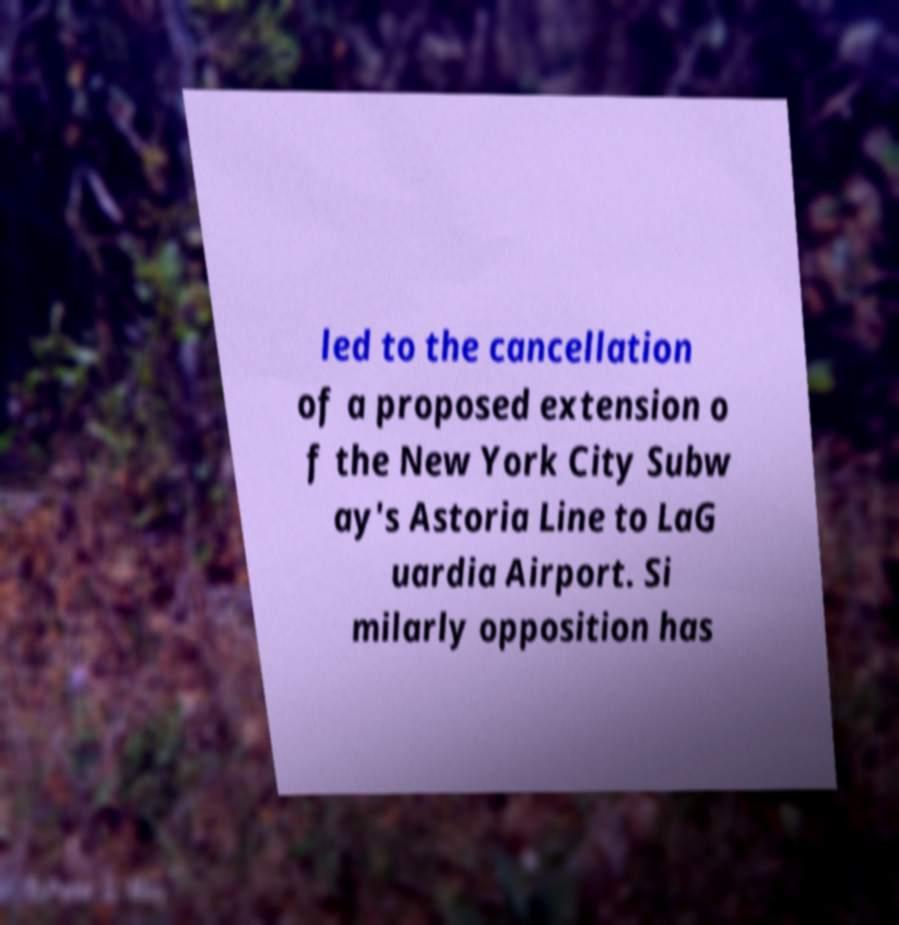Please identify and transcribe the text found in this image. led to the cancellation of a proposed extension o f the New York City Subw ay's Astoria Line to LaG uardia Airport. Si milarly opposition has 